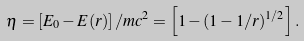Convert formula to latex. <formula><loc_0><loc_0><loc_500><loc_500>\eta = \left [ E _ { 0 } - E ( r ) \right ] / m c ^ { 2 } = \left [ 1 - ( 1 - 1 / r ) ^ { 1 / 2 } \right ] .</formula> 